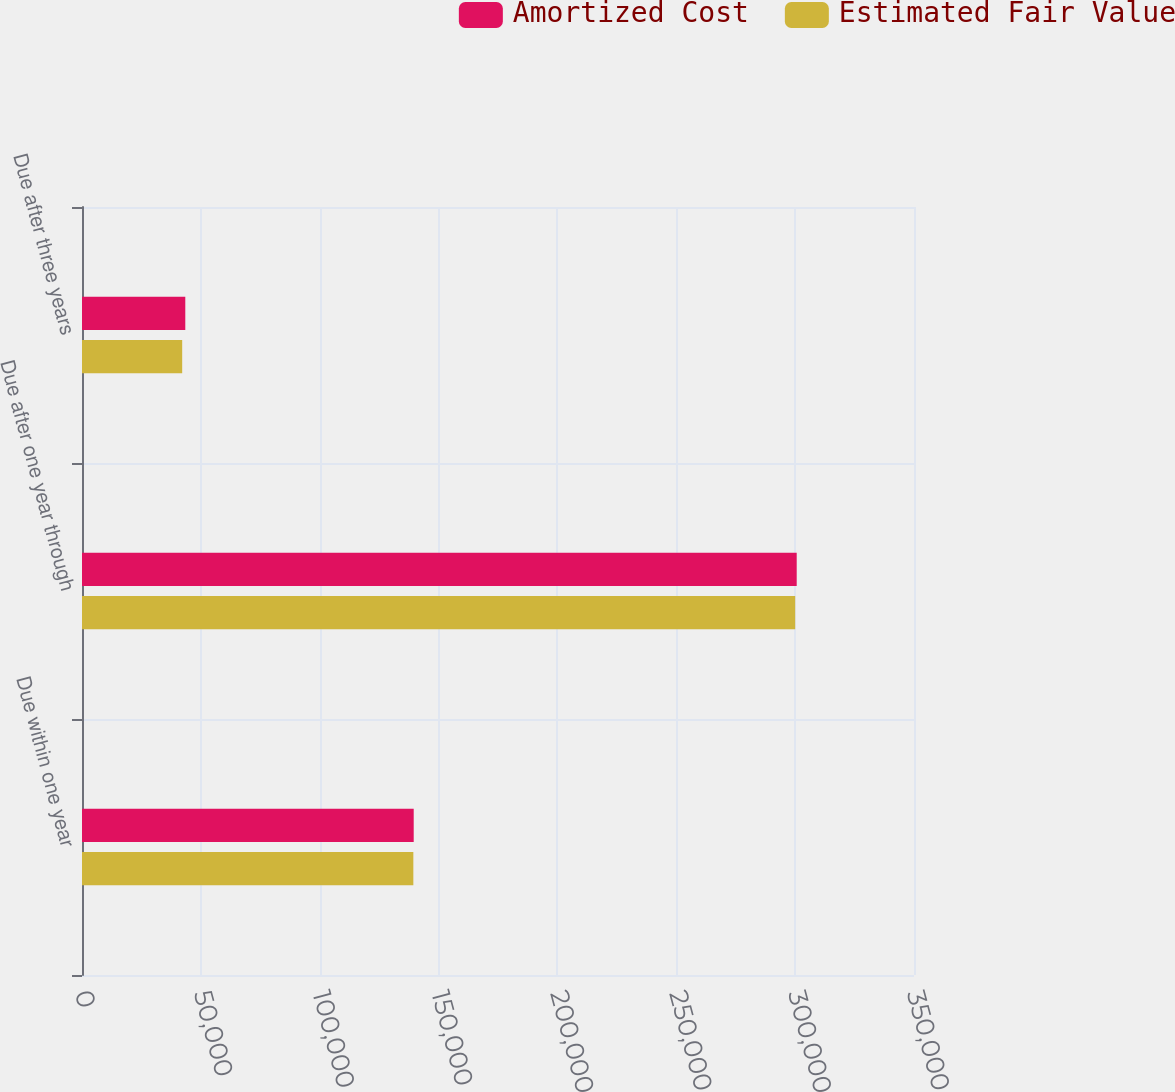Convert chart. <chart><loc_0><loc_0><loc_500><loc_500><stacked_bar_chart><ecel><fcel>Due within one year<fcel>Due after one year through<fcel>Due after three years<nl><fcel>Amortized Cost<fcel>139538<fcel>300659<fcel>43450<nl><fcel>Estimated Fair Value<fcel>139386<fcel>300021<fcel>42147<nl></chart> 